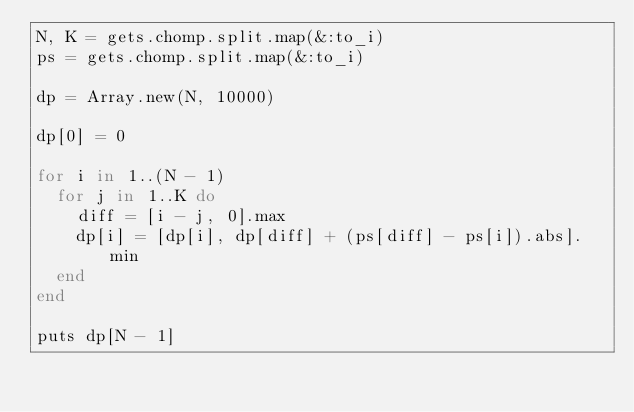<code> <loc_0><loc_0><loc_500><loc_500><_Ruby_>N, K = gets.chomp.split.map(&:to_i)
ps = gets.chomp.split.map(&:to_i)

dp = Array.new(N, 10000)

dp[0] = 0

for i in 1..(N - 1)
  for j in 1..K do
    diff = [i - j, 0].max
    dp[i] = [dp[i], dp[diff] + (ps[diff] - ps[i]).abs].min
  end
end

puts dp[N - 1]
</code> 